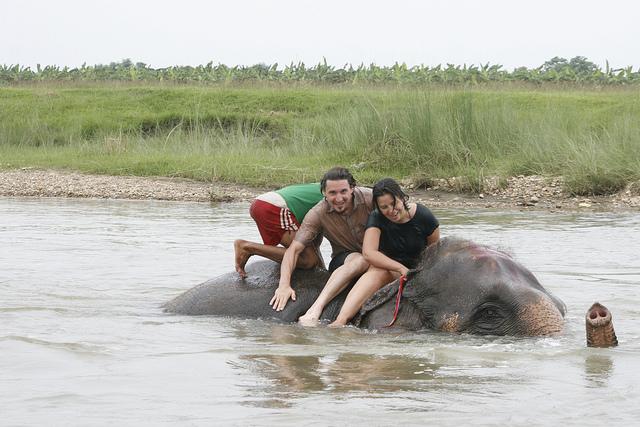Is this a river?
Be succinct. Yes. Is it sunny outside?
Give a very brief answer. No. What animal are the people on?
Write a very short answer. Elephant. Is most of the elephant submerged or above water?
Concise answer only. Submerged. 